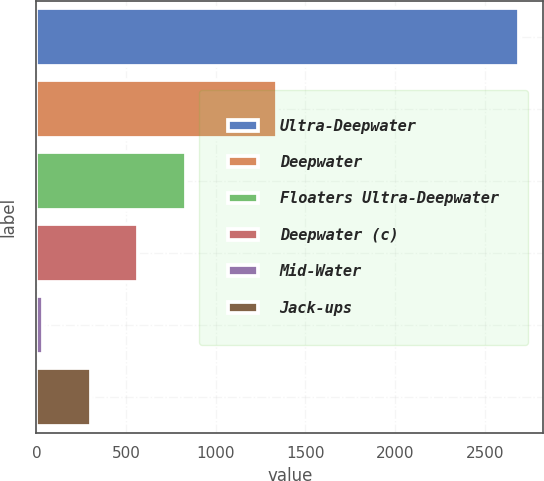<chart> <loc_0><loc_0><loc_500><loc_500><bar_chart><fcel>Ultra-Deepwater<fcel>Deepwater<fcel>Floaters Ultra-Deepwater<fcel>Deepwater (c)<fcel>Mid-Water<fcel>Jack-ups<nl><fcel>2690<fcel>1339<fcel>832.2<fcel>566.8<fcel>36<fcel>301.4<nl></chart> 